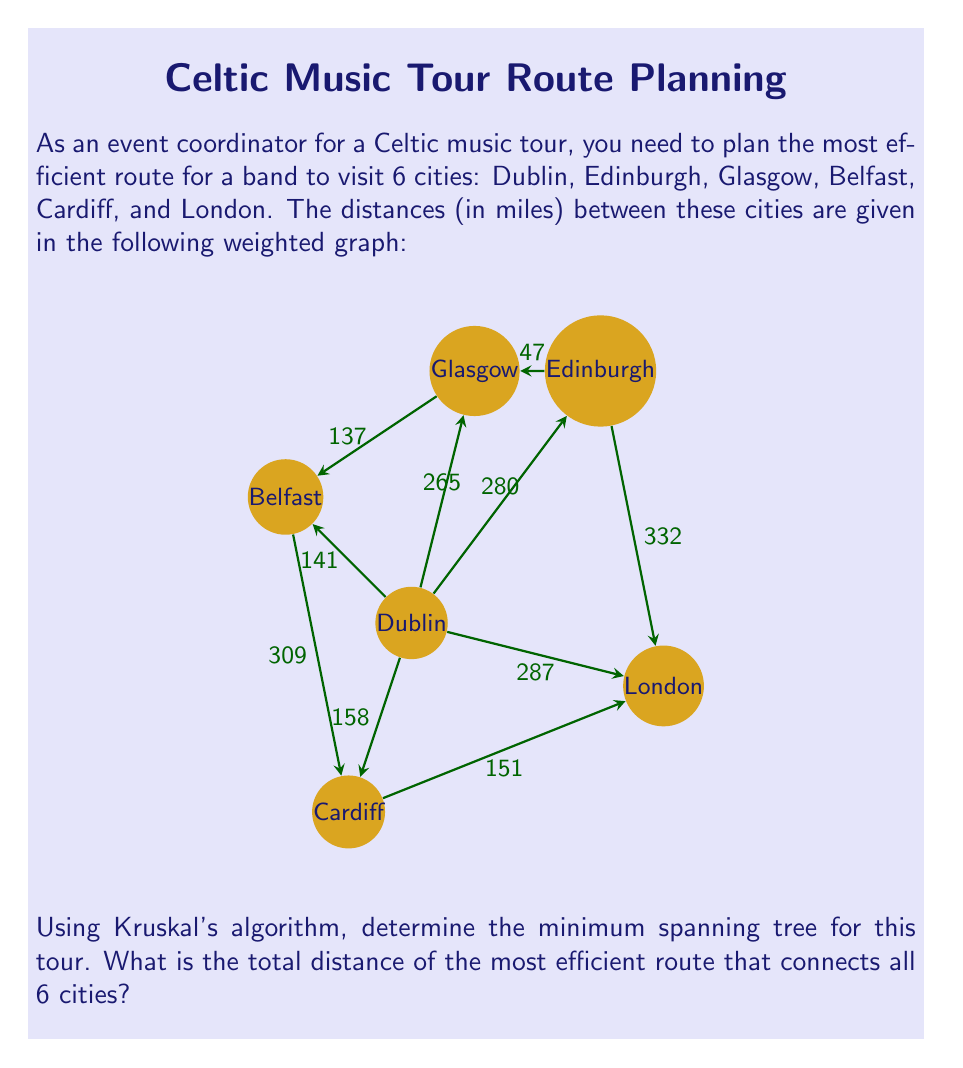Show me your answer to this math problem. To solve this problem using Kruskal's algorithm, we follow these steps:

1) First, we list all the edges and their weights in ascending order:
   Glasgow - Edinburgh: 47
   Dublin - Belfast: 141
   Glasgow - Belfast: 137
   Cardiff - London: 151
   Dublin - Cardiff: 158
   Dublin - Glasgow: 265
   Dublin - Edinburgh: 280
   Dublin - London: 287
   Belfast - Cardiff: 309
   Edinburgh - London: 332

2) We start with an empty set and add edges one by one, ensuring we don't create a cycle:

   a) Add Glasgow - Edinburgh (47)
   b) Add Dublin - Belfast (141)
   c) Add Cardiff - London (151)
   d) Add Dublin - Cardiff (158)

3) At this point, we have connected all 6 cities without creating any cycles. We stop here as we have our minimum spanning tree.

4) To calculate the total distance, we sum up the weights of the edges in our minimum spanning tree:

   $$ 47 + 141 + 151 + 158 = 497 $$

Therefore, the most efficient route connecting all 6 cities has a total distance of 497 miles.
Answer: 497 miles 